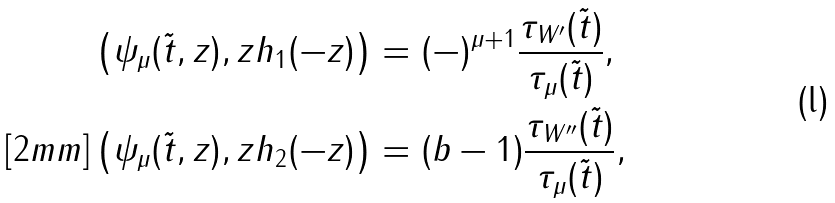<formula> <loc_0><loc_0><loc_500><loc_500>\left ( \psi _ { \mu } ( \tilde { t } , z ) , z h _ { 1 } ( - z ) \right ) & = ( - ) ^ { \mu + 1 } \frac { \tau _ { W ^ { \prime } } ( \tilde { t } ) } { \tau _ { \mu } ( \tilde { t } ) } , \\ [ 2 m m ] \left ( \psi _ { \mu } ( \tilde { t } , z ) , z h _ { 2 } ( - z ) \right ) & = ( b - 1 ) \frac { \tau _ { W ^ { \prime \prime } } ( \tilde { t } ) } { \tau _ { \mu } ( \tilde { t } ) } ,</formula> 